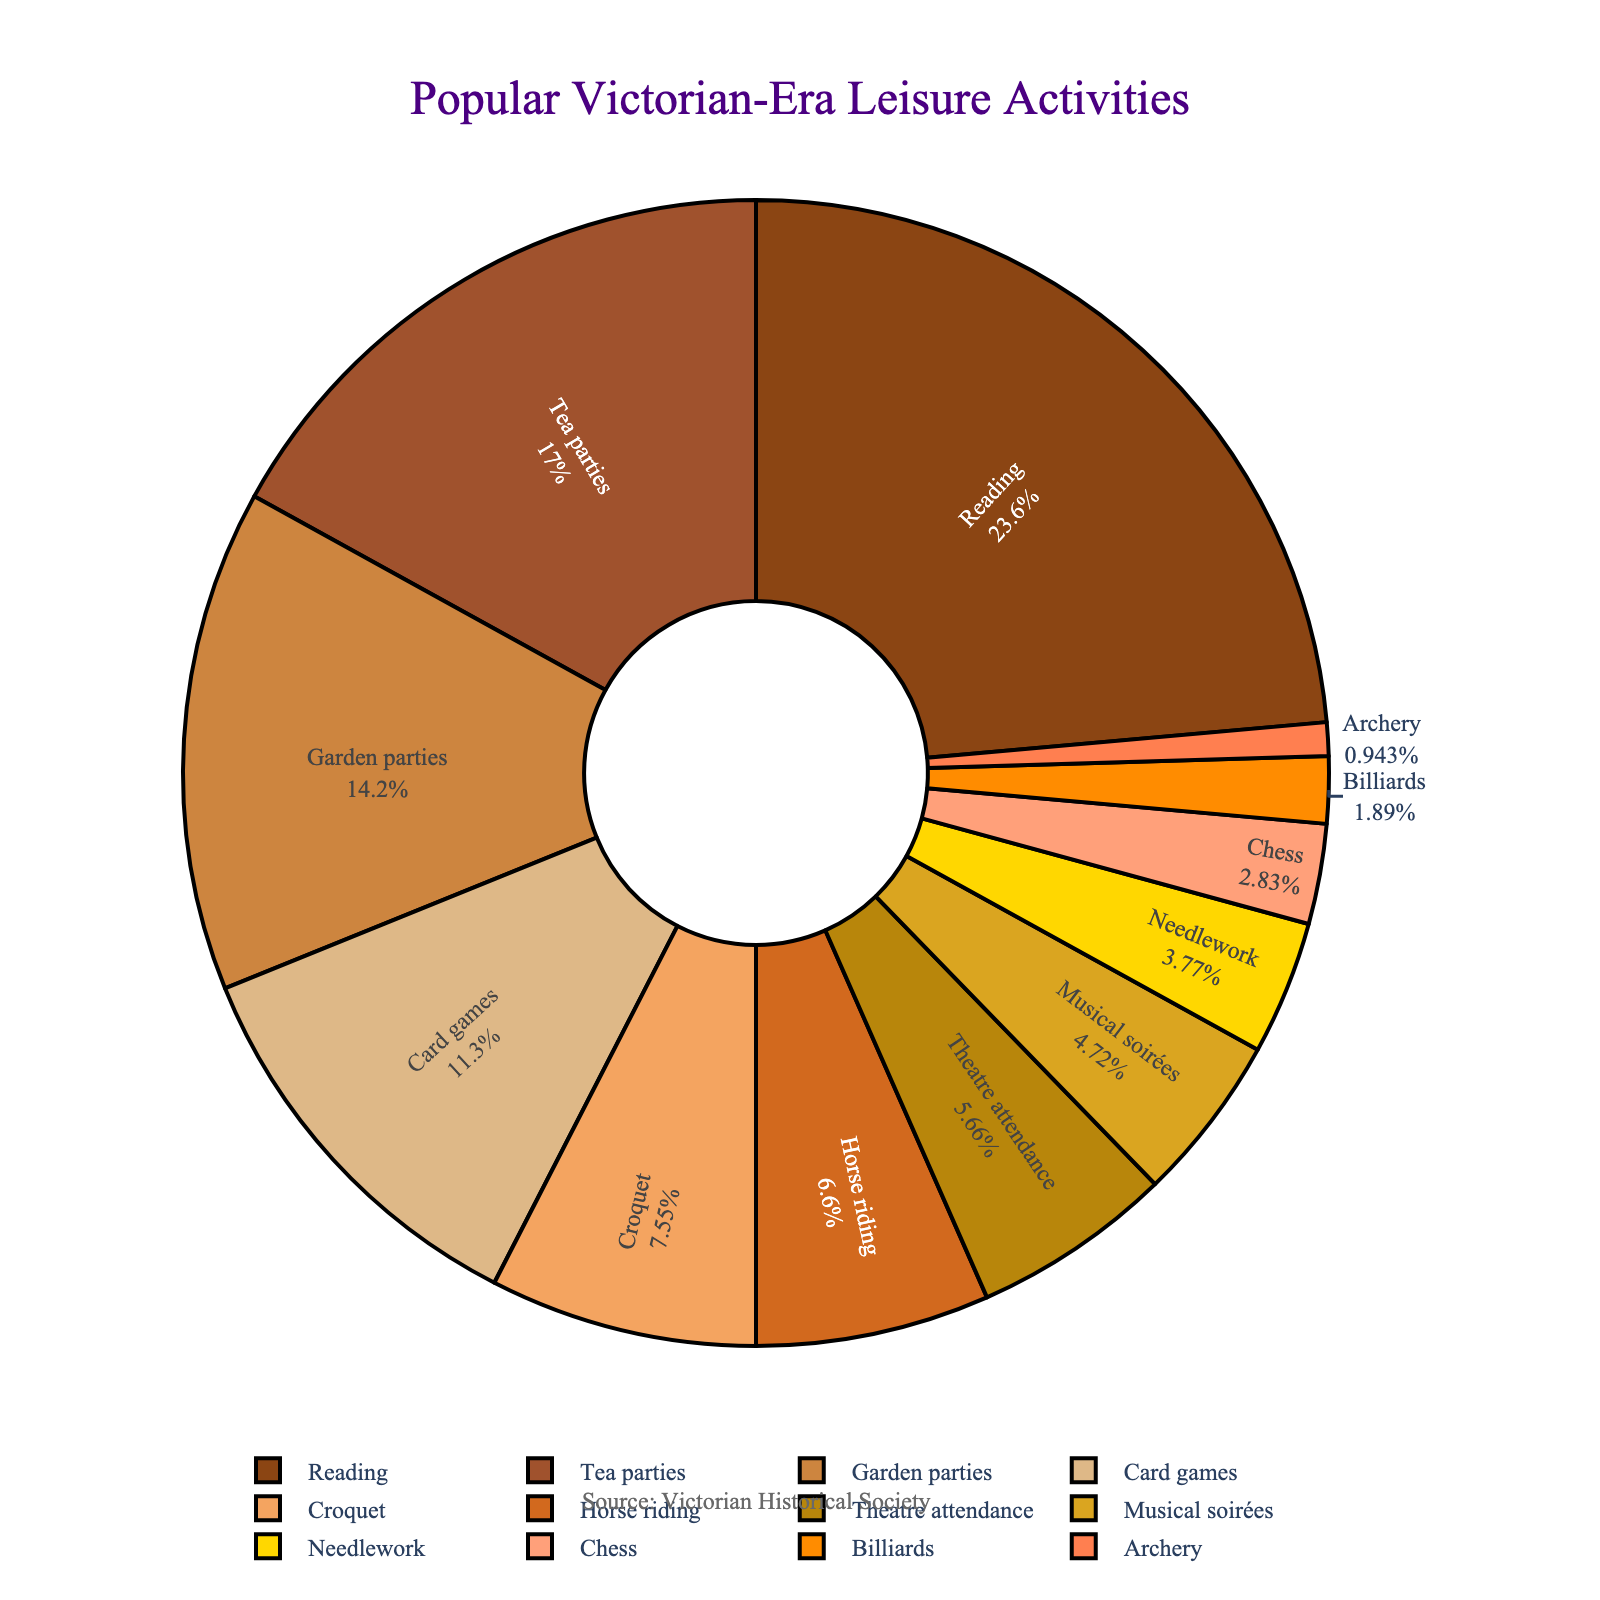What activity has the highest percentage of popularity? The pie chart shows that the activity with the largest segment is Reading, indicating it has the highest popularity.
Answer: Reading What is the combined percentage of Tea parties and Garden parties? According to the pie chart, Tea parties have 18% and Garden parties have 15%. Adding these together gives 18% + 15% = 33%.
Answer: 33% Which is more popular, Horse riding or Croquet? The pie chart shows Horse riding with 7% and Croquet with 8%. Comparing these values reveals Croquet is more popular by 1%.
Answer: Croquet List the activities that constitute less than 5% of the total. From the pie chart, the activities with less than 5% are Needlework (4%), Chess (3%), Billiards (2%), and Archery (1%).
Answer: Needlework, Chess, Billiards, Archery What is the difference in popularity between Card games and Theatre attendance? Card games have 12% and Theatre attendance has 6%. The difference is 12% - 6% = 6%.
Answer: 6% Which activities have a combined percentage of 25% or more? The pie chart shows that Reading (25%) alone already constitutes 25%. Additionally, Tea parties and Garden parties together sum up to 33%. So the activities with a combined percentage of 25% or more are Reading, and Tea parties plus Garden parties.
Answer: Reading, Tea parties and Garden parties Are there more indoor or outdoor activities? (Assume reading and card games are indoor, and croquet and horse riding are outdoor) Summing up the percentages: Reading (25%), Tea parties (18%), Musical soirées (5%), Theatre attendance (6%), Card games (12%), Needlework (4%), Chess (3%), Billiards (2%) equals 75% for indoor. Garden parties (15%), Croquet (8%), Horse riding (7%), Archery (1%) equals 31% for outdoor. 75% is greater than 31%, so there are more indoor activities.
Answer: Indoor activities What percentage of activities are related to games (Card games, Chess, Billiards, Croquet)? According to the pie chart: Card games (12%), Chess (3%), Billiards (2%), and Croquet (8%). Adding these together is 12% + 3% + 2% + 8% = 25%.
Answer: 25% 